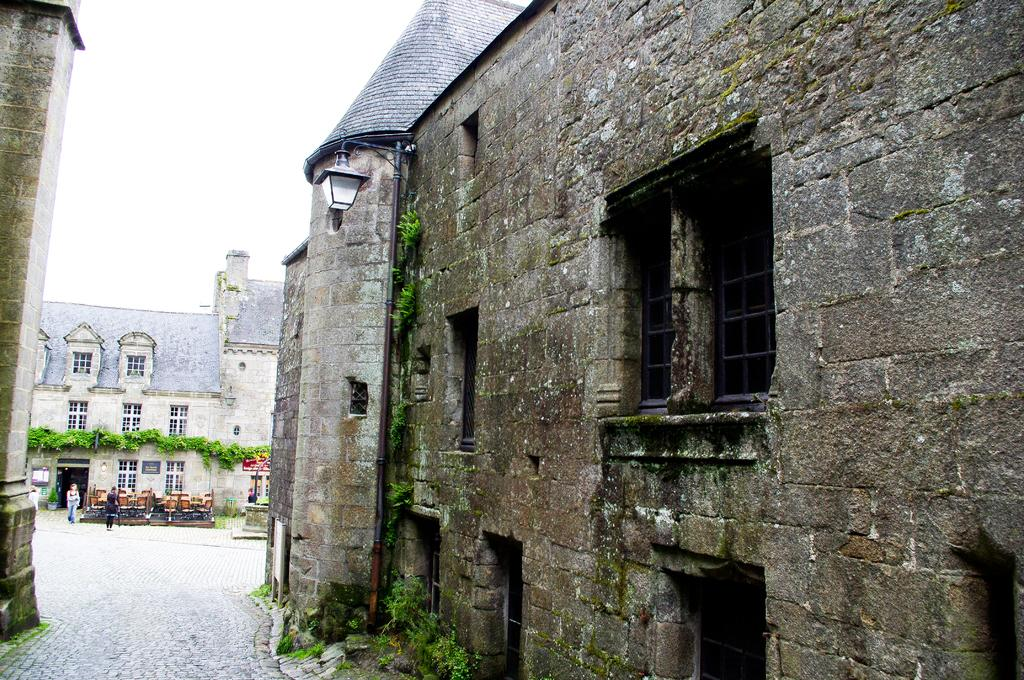What is the main subject in the middle of the image? There is a building and plants in the middle of the image. Can you describe the people on the left side of the image? There are two persons on the left side of the image. What type of wine is being served to the achiever in the image? There is no achiever or wine present in the image. 